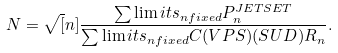Convert formula to latex. <formula><loc_0><loc_0><loc_500><loc_500>N = \sqrt { [ } n ] { \frac { \sum \lim i t s _ { n f i x e d } P _ { n } ^ { J E T S E T } } { \sum \lim i t s _ { n f i x e d } C ( V P S ) ( S U D ) R _ { n } } } .</formula> 